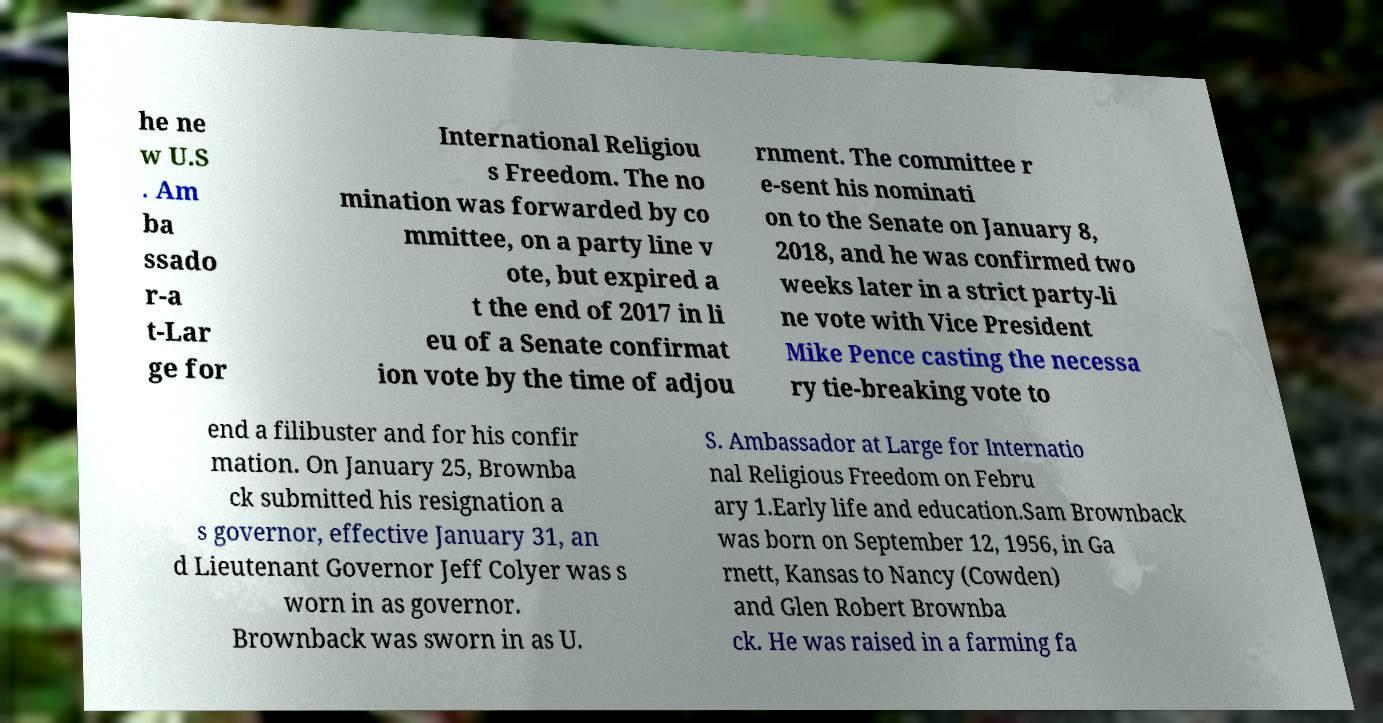For documentation purposes, I need the text within this image transcribed. Could you provide that? he ne w U.S . Am ba ssado r-a t-Lar ge for International Religiou s Freedom. The no mination was forwarded by co mmittee, on a party line v ote, but expired a t the end of 2017 in li eu of a Senate confirmat ion vote by the time of adjou rnment. The committee r e-sent his nominati on to the Senate on January 8, 2018, and he was confirmed two weeks later in a strict party-li ne vote with Vice President Mike Pence casting the necessa ry tie-breaking vote to end a filibuster and for his confir mation. On January 25, Brownba ck submitted his resignation a s governor, effective January 31, an d Lieutenant Governor Jeff Colyer was s worn in as governor. Brownback was sworn in as U. S. Ambassador at Large for Internatio nal Religious Freedom on Febru ary 1.Early life and education.Sam Brownback was born on September 12, 1956, in Ga rnett, Kansas to Nancy (Cowden) and Glen Robert Brownba ck. He was raised in a farming fa 